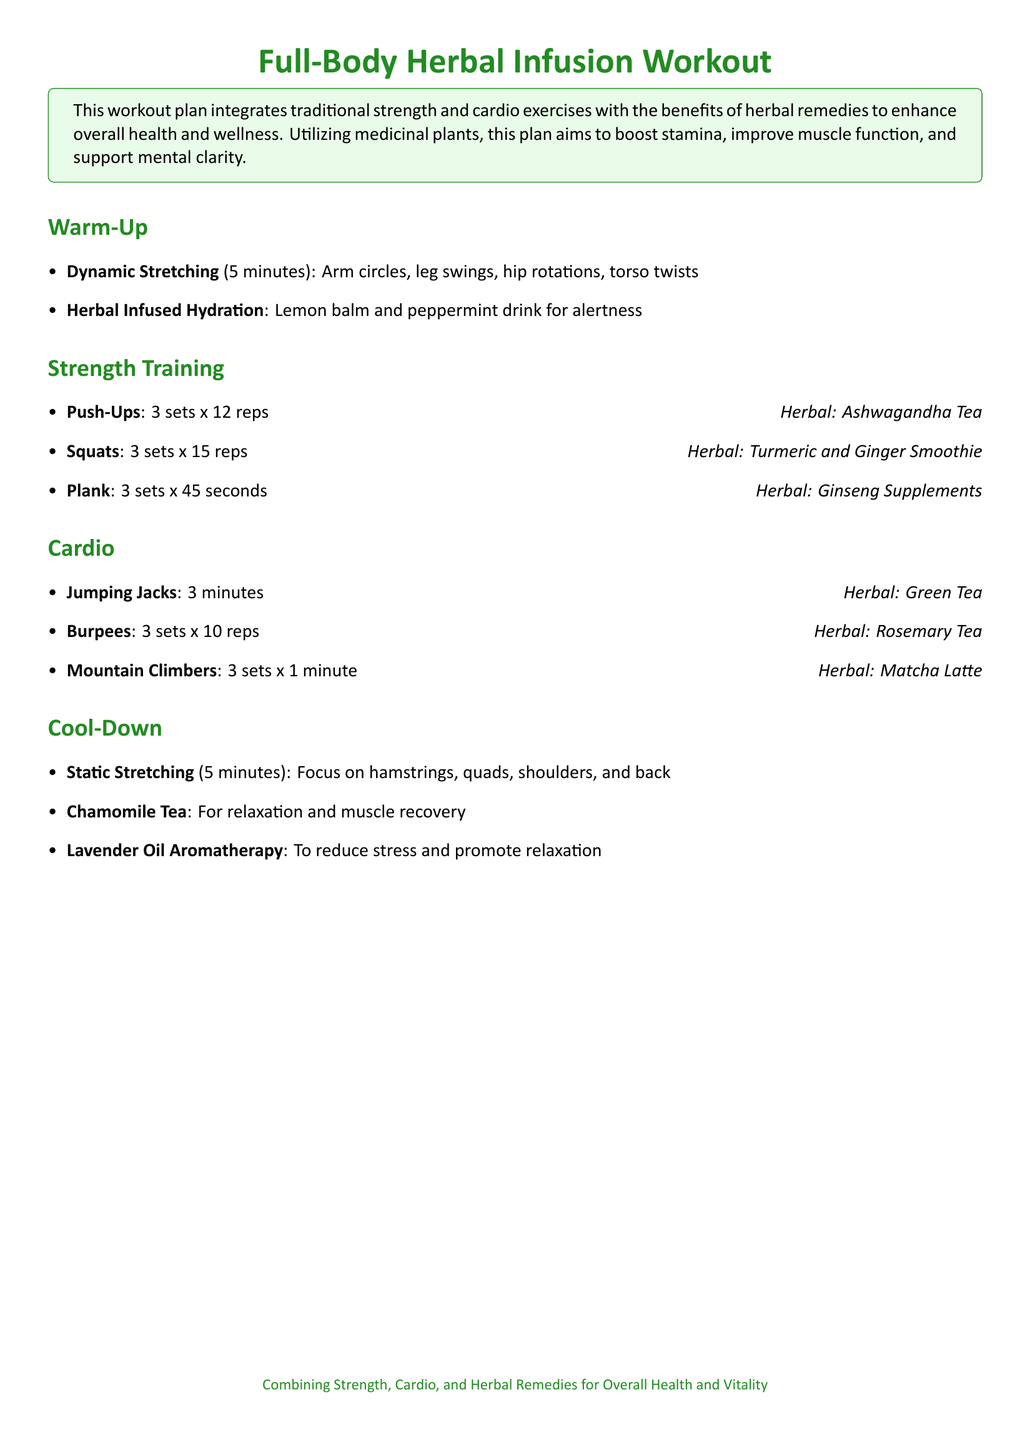what is the duration of dynamic stretching in the warm-up? The document states that dynamic stretching lasts for 5 minutes.
Answer: 5 minutes how many sets and reps for push-ups in strength training? The workout plan specifies 3 sets of 12 reps for push-ups.
Answer: 3 sets x 12 reps what herbal infusion is recommended during the cool-down? The document lists chamomile tea as the beverage for relaxation and muscle recovery during the cool-down.
Answer: Chamomile Tea which herbal remedy is paired with planks? According to the document, ginseng supplements are recommended alongside planks.
Answer: Ginseng Supplements what is the primary focus during the static stretching part of the cool-down? The focus during static stretching is on hamstrings, quads, shoulders, and back as indicated in the document.
Answer: Hamstrings, quads, shoulders, and back how long is the duration for mountain climbers in cardio? The workout plan states that mountain climbers should last for 3 sets of 1 minute each.
Answer: 3 sets x 1 minute what is the purpose of herbal remedies in this workout plan? The document states that herbal remedies are used to enhance overall health and wellness.
Answer: Enhance overall health and wellness which herbal drink is used for hydration in the warm-up? The warm-up section indicates that a lemon balm and peppermint drink is used for hydration.
Answer: Lemon balm and peppermint drink 